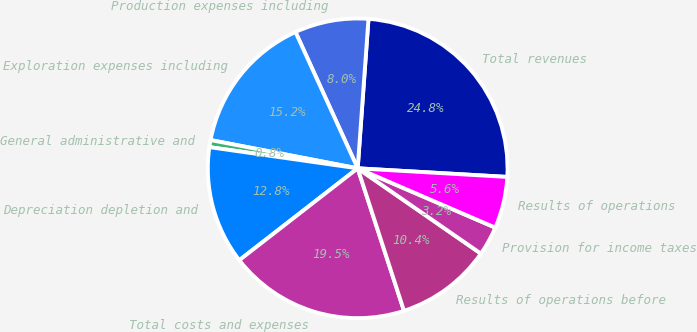<chart> <loc_0><loc_0><loc_500><loc_500><pie_chart><fcel>Total revenues<fcel>Production expenses including<fcel>Exploration expenses including<fcel>General administrative and<fcel>Depreciation depletion and<fcel>Total costs and expenses<fcel>Results of operations before<fcel>Provision for income taxes<fcel>Results of operations<nl><fcel>24.76%<fcel>7.96%<fcel>15.16%<fcel>0.76%<fcel>12.76%<fcel>19.49%<fcel>10.36%<fcel>3.16%<fcel>5.56%<nl></chart> 